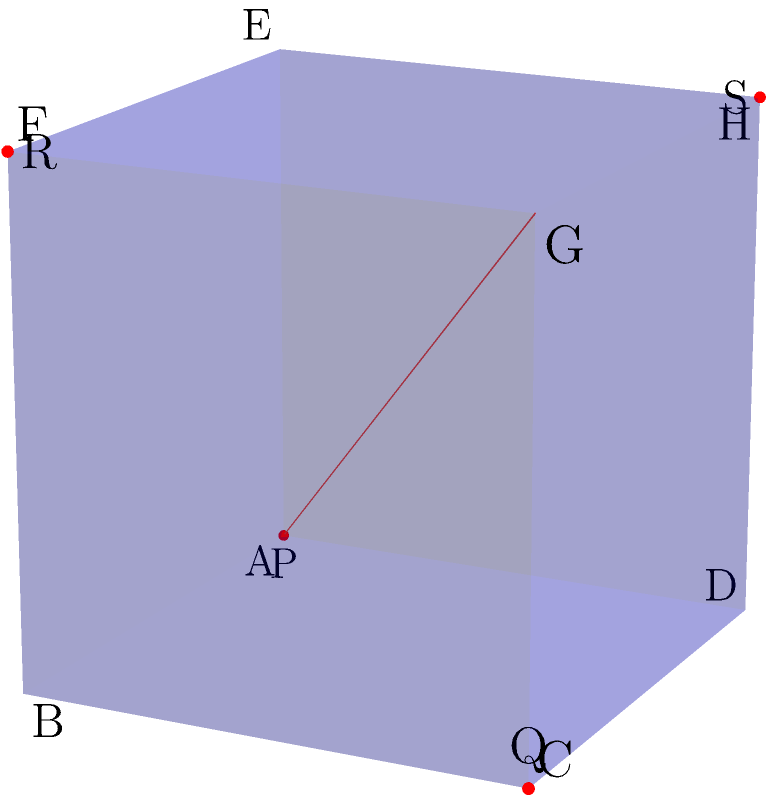In a network security model, a cube represents a multi-layered firewall system. A plane intersects this cube, creating a cross-section that symbolizes a specific security policy cutting through multiple layers. The cube has a side length of 6 units, and the plane passes through points P(0,0,0), Q(6,6,0), R(6,0,6), and S(0,6,6). What is the area of the resulting cross-section, which represents the scope of the security policy across different firewall layers? Let's approach this step-by-step:

1) The plane intersects the cube at four points, forming a quadrilateral PQRS.

2) This quadrilateral is actually a square. We can prove this by showing that its diagonals are equal and perpendicular:
   
   PR = $\sqrt{6^2 + 6^2 + 6^2} = 6\sqrt{3}$
   QS = $\sqrt{6^2 + 6^2 + 6^2} = 6\sqrt{3}$

   The diagonals are equal, and they intersect at the cube's center (3,3,3), making them perpendicular.

3) To find the area of this square, we need to calculate the length of its side.

4) We can do this by finding the distance between P and Q:

   PQ = $\sqrt{(6-0)^2 + (6-0)^2 + (0-0)^2} = \sqrt{72} = 6\sqrt{2}$

5) Now that we have the side length, we can calculate the area:

   Area = $(6\sqrt{2})^2 = 72$ square units

This area represents the scope of the security policy across different firewall layers in our network security model.
Answer: 72 square units 